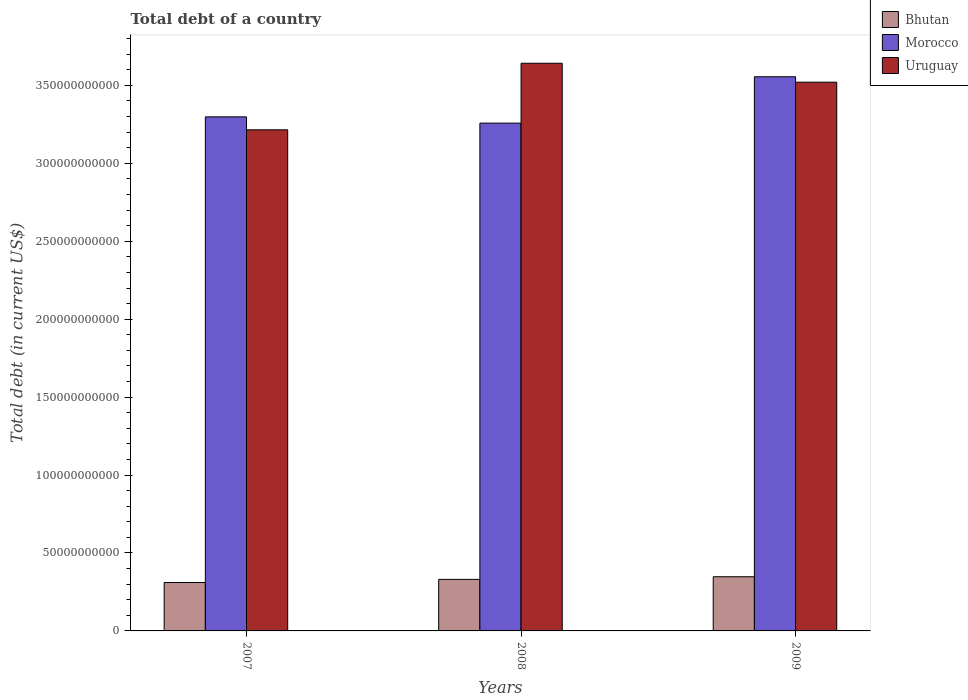Are the number of bars per tick equal to the number of legend labels?
Offer a terse response. Yes. How many bars are there on the 2nd tick from the right?
Provide a succinct answer. 3. What is the label of the 3rd group of bars from the left?
Provide a short and direct response. 2009. What is the debt in Bhutan in 2007?
Keep it short and to the point. 3.11e+1. Across all years, what is the maximum debt in Uruguay?
Your answer should be compact. 3.64e+11. Across all years, what is the minimum debt in Bhutan?
Your answer should be compact. 3.11e+1. In which year was the debt in Bhutan maximum?
Provide a short and direct response. 2009. In which year was the debt in Uruguay minimum?
Offer a very short reply. 2007. What is the total debt in Morocco in the graph?
Your response must be concise. 1.01e+12. What is the difference between the debt in Bhutan in 2008 and that in 2009?
Your answer should be compact. -1.69e+09. What is the difference between the debt in Uruguay in 2008 and the debt in Morocco in 2009?
Offer a terse response. 8.66e+09. What is the average debt in Morocco per year?
Your response must be concise. 3.37e+11. In the year 2007, what is the difference between the debt in Uruguay and debt in Bhutan?
Offer a very short reply. 2.90e+11. What is the ratio of the debt in Bhutan in 2007 to that in 2008?
Give a very brief answer. 0.94. Is the debt in Uruguay in 2007 less than that in 2009?
Provide a short and direct response. Yes. Is the difference between the debt in Uruguay in 2007 and 2008 greater than the difference between the debt in Bhutan in 2007 and 2008?
Ensure brevity in your answer.  No. What is the difference between the highest and the second highest debt in Morocco?
Offer a terse response. 2.57e+1. What is the difference between the highest and the lowest debt in Bhutan?
Give a very brief answer. 3.70e+09. Is the sum of the debt in Morocco in 2007 and 2009 greater than the maximum debt in Uruguay across all years?
Your answer should be compact. Yes. What does the 2nd bar from the left in 2008 represents?
Your answer should be very brief. Morocco. What does the 2nd bar from the right in 2009 represents?
Offer a very short reply. Morocco. How many bars are there?
Provide a short and direct response. 9. Are all the bars in the graph horizontal?
Your answer should be very brief. No. Are the values on the major ticks of Y-axis written in scientific E-notation?
Offer a very short reply. No. Does the graph contain any zero values?
Offer a terse response. No. Does the graph contain grids?
Keep it short and to the point. No. Where does the legend appear in the graph?
Make the answer very short. Top right. How many legend labels are there?
Give a very brief answer. 3. What is the title of the graph?
Offer a terse response. Total debt of a country. What is the label or title of the Y-axis?
Offer a terse response. Total debt (in current US$). What is the Total debt (in current US$) of Bhutan in 2007?
Provide a short and direct response. 3.11e+1. What is the Total debt (in current US$) of Morocco in 2007?
Provide a short and direct response. 3.30e+11. What is the Total debt (in current US$) of Uruguay in 2007?
Your answer should be compact. 3.22e+11. What is the Total debt (in current US$) in Bhutan in 2008?
Provide a succinct answer. 3.31e+1. What is the Total debt (in current US$) in Morocco in 2008?
Provide a short and direct response. 3.26e+11. What is the Total debt (in current US$) in Uruguay in 2008?
Offer a terse response. 3.64e+11. What is the Total debt (in current US$) in Bhutan in 2009?
Your answer should be very brief. 3.48e+1. What is the Total debt (in current US$) in Morocco in 2009?
Make the answer very short. 3.56e+11. What is the Total debt (in current US$) in Uruguay in 2009?
Your response must be concise. 3.52e+11. Across all years, what is the maximum Total debt (in current US$) of Bhutan?
Provide a succinct answer. 3.48e+1. Across all years, what is the maximum Total debt (in current US$) of Morocco?
Keep it short and to the point. 3.56e+11. Across all years, what is the maximum Total debt (in current US$) in Uruguay?
Your response must be concise. 3.64e+11. Across all years, what is the minimum Total debt (in current US$) of Bhutan?
Give a very brief answer. 3.11e+1. Across all years, what is the minimum Total debt (in current US$) of Morocco?
Your answer should be very brief. 3.26e+11. Across all years, what is the minimum Total debt (in current US$) in Uruguay?
Your answer should be compact. 3.22e+11. What is the total Total debt (in current US$) in Bhutan in the graph?
Your answer should be compact. 9.89e+1. What is the total Total debt (in current US$) in Morocco in the graph?
Provide a succinct answer. 1.01e+12. What is the total Total debt (in current US$) in Uruguay in the graph?
Make the answer very short. 1.04e+12. What is the difference between the Total debt (in current US$) in Bhutan in 2007 and that in 2008?
Give a very brief answer. -2.01e+09. What is the difference between the Total debt (in current US$) in Morocco in 2007 and that in 2008?
Give a very brief answer. 4.02e+09. What is the difference between the Total debt (in current US$) in Uruguay in 2007 and that in 2008?
Provide a succinct answer. -4.27e+1. What is the difference between the Total debt (in current US$) in Bhutan in 2007 and that in 2009?
Give a very brief answer. -3.70e+09. What is the difference between the Total debt (in current US$) of Morocco in 2007 and that in 2009?
Make the answer very short. -2.57e+1. What is the difference between the Total debt (in current US$) in Uruguay in 2007 and that in 2009?
Offer a very short reply. -3.06e+1. What is the difference between the Total debt (in current US$) in Bhutan in 2008 and that in 2009?
Give a very brief answer. -1.69e+09. What is the difference between the Total debt (in current US$) of Morocco in 2008 and that in 2009?
Offer a very short reply. -2.98e+1. What is the difference between the Total debt (in current US$) in Uruguay in 2008 and that in 2009?
Offer a very short reply. 1.21e+1. What is the difference between the Total debt (in current US$) of Bhutan in 2007 and the Total debt (in current US$) of Morocco in 2008?
Offer a terse response. -2.95e+11. What is the difference between the Total debt (in current US$) of Bhutan in 2007 and the Total debt (in current US$) of Uruguay in 2008?
Keep it short and to the point. -3.33e+11. What is the difference between the Total debt (in current US$) in Morocco in 2007 and the Total debt (in current US$) in Uruguay in 2008?
Keep it short and to the point. -3.44e+1. What is the difference between the Total debt (in current US$) in Bhutan in 2007 and the Total debt (in current US$) in Morocco in 2009?
Your answer should be very brief. -3.25e+11. What is the difference between the Total debt (in current US$) of Bhutan in 2007 and the Total debt (in current US$) of Uruguay in 2009?
Give a very brief answer. -3.21e+11. What is the difference between the Total debt (in current US$) in Morocco in 2007 and the Total debt (in current US$) in Uruguay in 2009?
Your answer should be compact. -2.22e+1. What is the difference between the Total debt (in current US$) in Bhutan in 2008 and the Total debt (in current US$) in Morocco in 2009?
Keep it short and to the point. -3.22e+11. What is the difference between the Total debt (in current US$) in Bhutan in 2008 and the Total debt (in current US$) in Uruguay in 2009?
Offer a very short reply. -3.19e+11. What is the difference between the Total debt (in current US$) in Morocco in 2008 and the Total debt (in current US$) in Uruguay in 2009?
Provide a succinct answer. -2.63e+1. What is the average Total debt (in current US$) of Bhutan per year?
Your answer should be compact. 3.30e+1. What is the average Total debt (in current US$) in Morocco per year?
Keep it short and to the point. 3.37e+11. What is the average Total debt (in current US$) in Uruguay per year?
Your response must be concise. 3.46e+11. In the year 2007, what is the difference between the Total debt (in current US$) in Bhutan and Total debt (in current US$) in Morocco?
Your response must be concise. -2.99e+11. In the year 2007, what is the difference between the Total debt (in current US$) in Bhutan and Total debt (in current US$) in Uruguay?
Ensure brevity in your answer.  -2.90e+11. In the year 2007, what is the difference between the Total debt (in current US$) in Morocco and Total debt (in current US$) in Uruguay?
Your answer should be compact. 8.32e+09. In the year 2008, what is the difference between the Total debt (in current US$) in Bhutan and Total debt (in current US$) in Morocco?
Your response must be concise. -2.93e+11. In the year 2008, what is the difference between the Total debt (in current US$) of Bhutan and Total debt (in current US$) of Uruguay?
Make the answer very short. -3.31e+11. In the year 2008, what is the difference between the Total debt (in current US$) of Morocco and Total debt (in current US$) of Uruguay?
Ensure brevity in your answer.  -3.84e+1. In the year 2009, what is the difference between the Total debt (in current US$) of Bhutan and Total debt (in current US$) of Morocco?
Make the answer very short. -3.21e+11. In the year 2009, what is the difference between the Total debt (in current US$) of Bhutan and Total debt (in current US$) of Uruguay?
Offer a terse response. -3.17e+11. In the year 2009, what is the difference between the Total debt (in current US$) in Morocco and Total debt (in current US$) in Uruguay?
Ensure brevity in your answer.  3.49e+09. What is the ratio of the Total debt (in current US$) of Bhutan in 2007 to that in 2008?
Your answer should be very brief. 0.94. What is the ratio of the Total debt (in current US$) of Morocco in 2007 to that in 2008?
Your answer should be very brief. 1.01. What is the ratio of the Total debt (in current US$) in Uruguay in 2007 to that in 2008?
Make the answer very short. 0.88. What is the ratio of the Total debt (in current US$) of Bhutan in 2007 to that in 2009?
Give a very brief answer. 0.89. What is the ratio of the Total debt (in current US$) of Morocco in 2007 to that in 2009?
Your response must be concise. 0.93. What is the ratio of the Total debt (in current US$) in Uruguay in 2007 to that in 2009?
Ensure brevity in your answer.  0.91. What is the ratio of the Total debt (in current US$) of Bhutan in 2008 to that in 2009?
Make the answer very short. 0.95. What is the ratio of the Total debt (in current US$) in Morocco in 2008 to that in 2009?
Provide a succinct answer. 0.92. What is the ratio of the Total debt (in current US$) in Uruguay in 2008 to that in 2009?
Make the answer very short. 1.03. What is the difference between the highest and the second highest Total debt (in current US$) in Bhutan?
Provide a short and direct response. 1.69e+09. What is the difference between the highest and the second highest Total debt (in current US$) of Morocco?
Offer a very short reply. 2.57e+1. What is the difference between the highest and the second highest Total debt (in current US$) in Uruguay?
Offer a terse response. 1.21e+1. What is the difference between the highest and the lowest Total debt (in current US$) of Bhutan?
Give a very brief answer. 3.70e+09. What is the difference between the highest and the lowest Total debt (in current US$) in Morocco?
Provide a succinct answer. 2.98e+1. What is the difference between the highest and the lowest Total debt (in current US$) of Uruguay?
Give a very brief answer. 4.27e+1. 